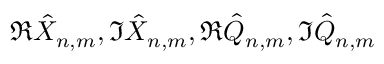<formula> <loc_0><loc_0><loc_500><loc_500>\Re \hat { X } _ { n , m } , \Im \hat { X } _ { n , m } , \Re \hat { Q } _ { n , m } , \Im \hat { Q } _ { n , m }</formula> 